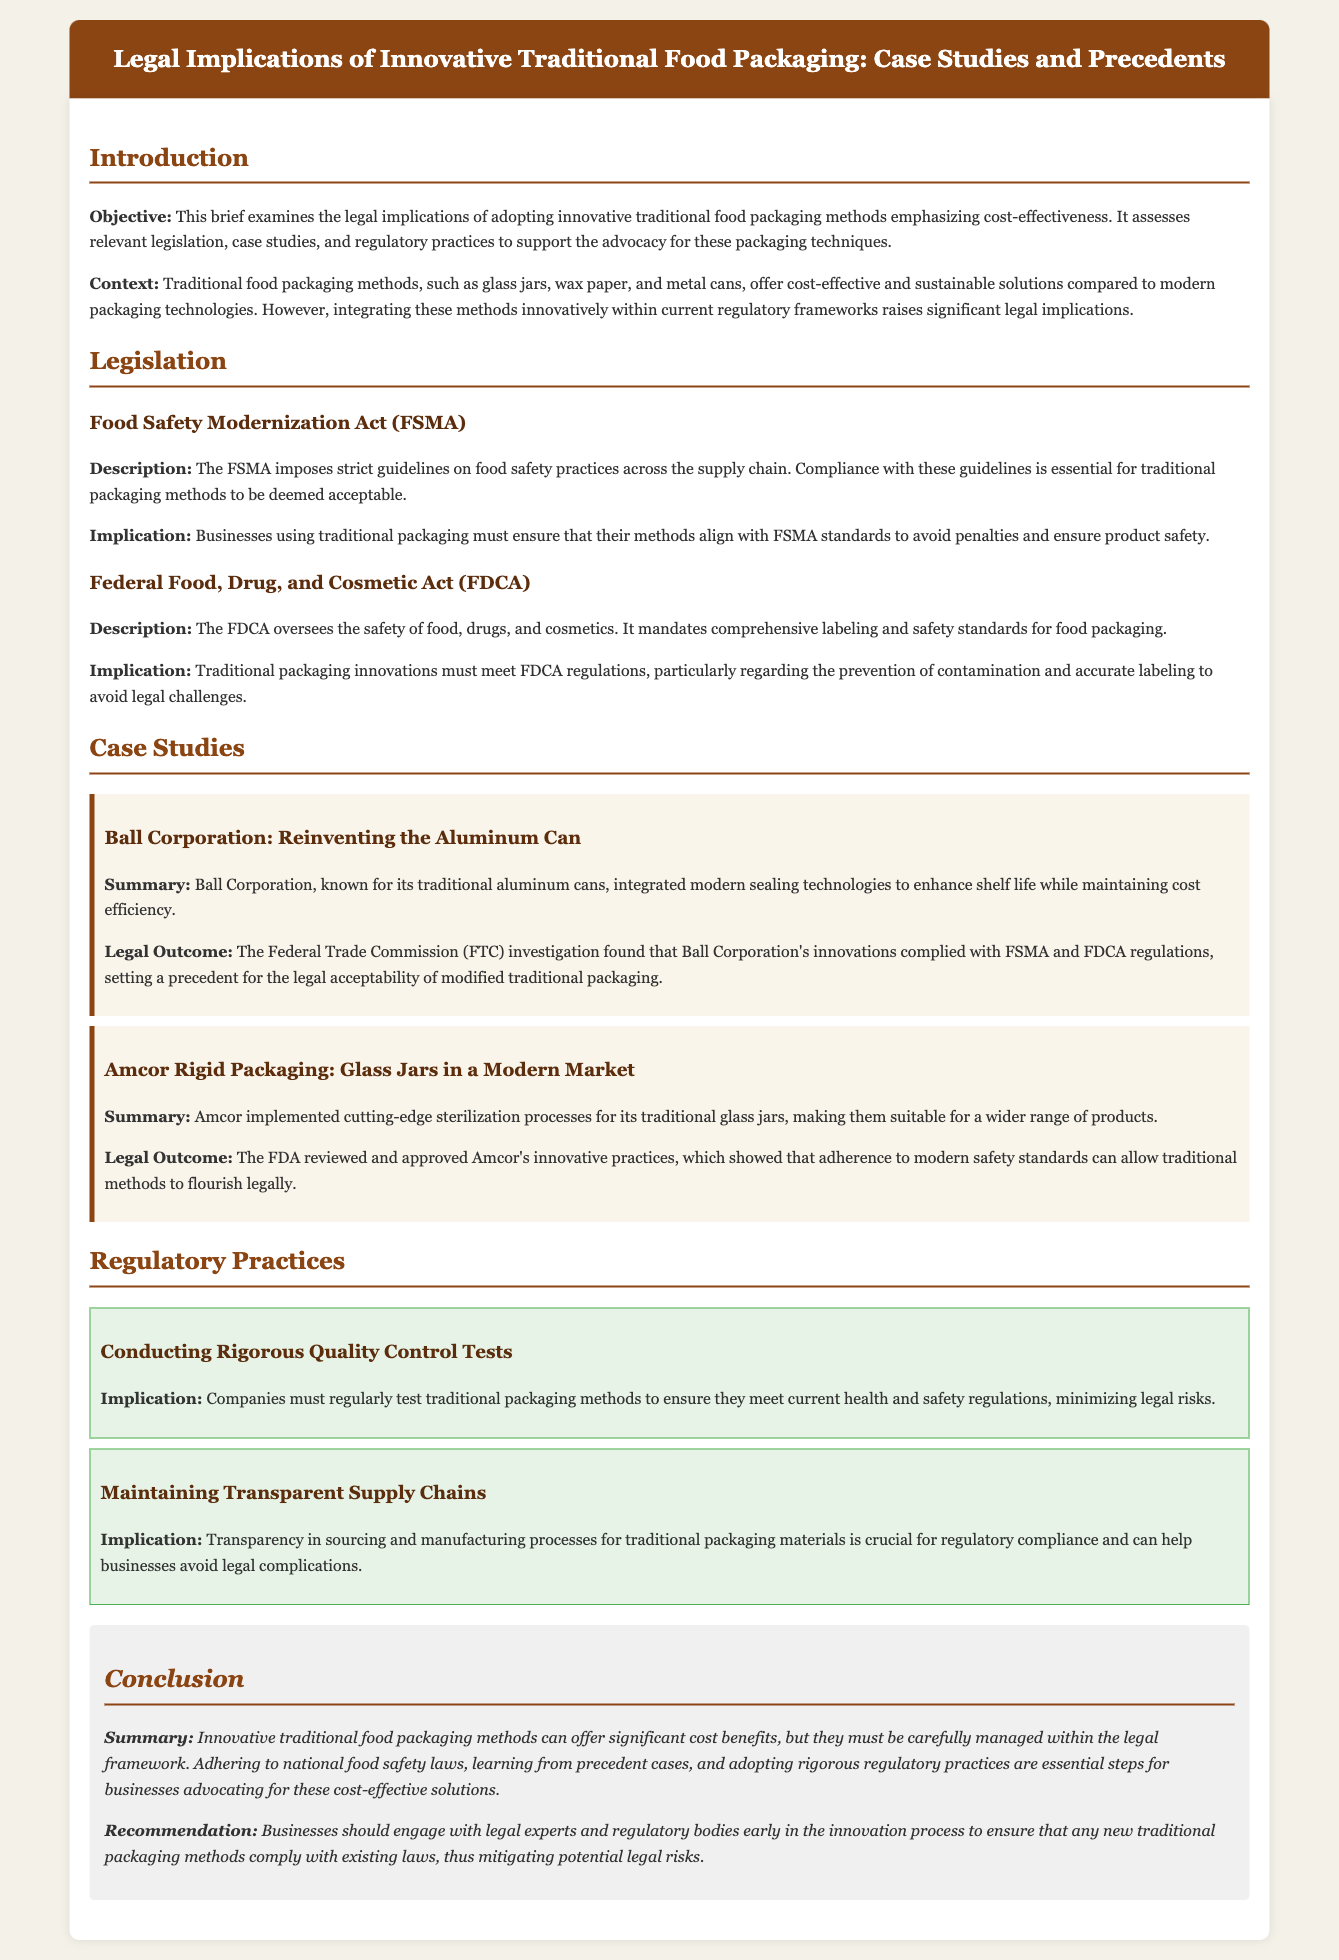what does the objective of the brief examine? The objective outlines the examination of legal implications related to traditional food packaging while emphasizing cost-effectiveness.
Answer: legal implications of adopting innovative traditional food packaging methods emphasizing cost-effectiveness what act imposes guidelines on food safety practices? The brief mentions the Food Safety Modernization Act, which outlines food safety guidelines.
Answer: Food Safety Modernization Act who conducted an investigation on Ball Corporation's packaging? The brief states that the Federal Trade Commission conducted the investigation.
Answer: Federal Trade Commission what type of packaging method did Amcor implement? It details that Amcor implemented sterilization processes for glass jars.
Answer: glass jars what must companies do to minimize legal risks? The document suggests that rigorous quality control tests should be conducted.
Answer: Conducting Rigorous Quality Control Tests how many case studies are presented in the brief? The brief presents two case studies concerning traditional packaging.
Answer: two what is essential for businesses advocating for traditional packaging? It concludes that engaging with legal experts early in the innovation process is crucial.
Answer: engage with legal experts which section outlines implications related to regulatory practices? The section titled "Regulatory Practices" addresses the implications.
Answer: Regulatory Practices what is a recommendation for businesses in the conclusion? The brief recommends early engagement with regulatory bodies during the innovation process.
Answer: engage with legal experts and regulatory bodies early in the innovation process 